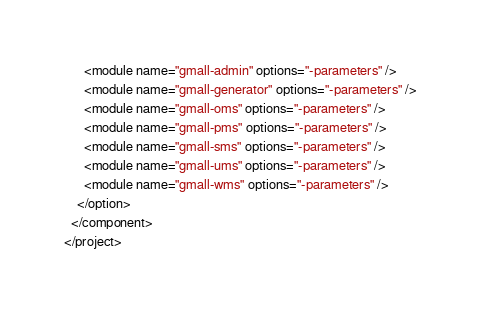Convert code to text. <code><loc_0><loc_0><loc_500><loc_500><_XML_>      <module name="gmall-admin" options="-parameters" />
      <module name="gmall-generator" options="-parameters" />
      <module name="gmall-oms" options="-parameters" />
      <module name="gmall-pms" options="-parameters" />
      <module name="gmall-sms" options="-parameters" />
      <module name="gmall-ums" options="-parameters" />
      <module name="gmall-wms" options="-parameters" />
    </option>
  </component>
</project></code> 